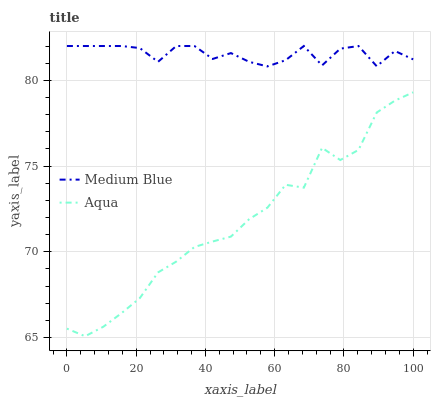Does Medium Blue have the minimum area under the curve?
Answer yes or no. No. Is Medium Blue the smoothest?
Answer yes or no. No. Does Medium Blue have the lowest value?
Answer yes or no. No. Is Aqua less than Medium Blue?
Answer yes or no. Yes. Is Medium Blue greater than Aqua?
Answer yes or no. Yes. Does Aqua intersect Medium Blue?
Answer yes or no. No. 